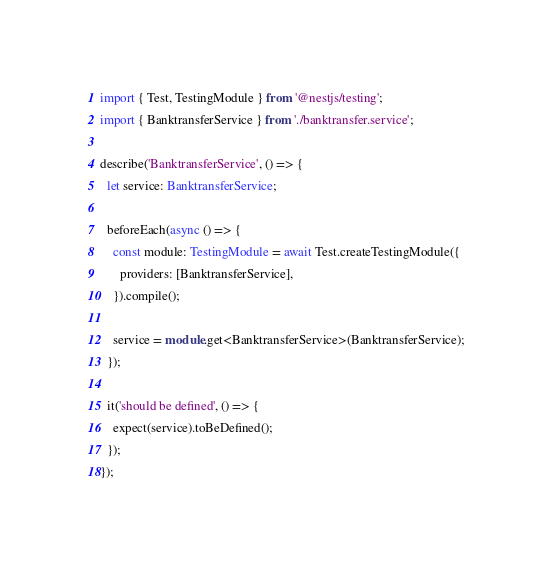Convert code to text. <code><loc_0><loc_0><loc_500><loc_500><_TypeScript_>import { Test, TestingModule } from '@nestjs/testing';
import { BanktransferService } from './banktransfer.service';

describe('BanktransferService', () => {
  let service: BanktransferService;

  beforeEach(async () => {
    const module: TestingModule = await Test.createTestingModule({
      providers: [BanktransferService],
    }).compile();

    service = module.get<BanktransferService>(BanktransferService);
  });

  it('should be defined', () => {
    expect(service).toBeDefined();
  });
});
</code> 